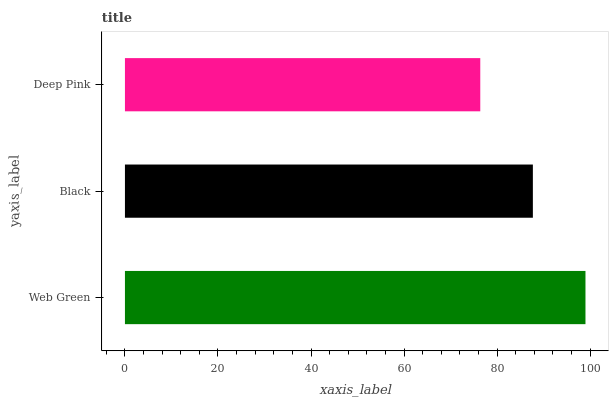Is Deep Pink the minimum?
Answer yes or no. Yes. Is Web Green the maximum?
Answer yes or no. Yes. Is Black the minimum?
Answer yes or no. No. Is Black the maximum?
Answer yes or no. No. Is Web Green greater than Black?
Answer yes or no. Yes. Is Black less than Web Green?
Answer yes or no. Yes. Is Black greater than Web Green?
Answer yes or no. No. Is Web Green less than Black?
Answer yes or no. No. Is Black the high median?
Answer yes or no. Yes. Is Black the low median?
Answer yes or no. Yes. Is Deep Pink the high median?
Answer yes or no. No. Is Deep Pink the low median?
Answer yes or no. No. 